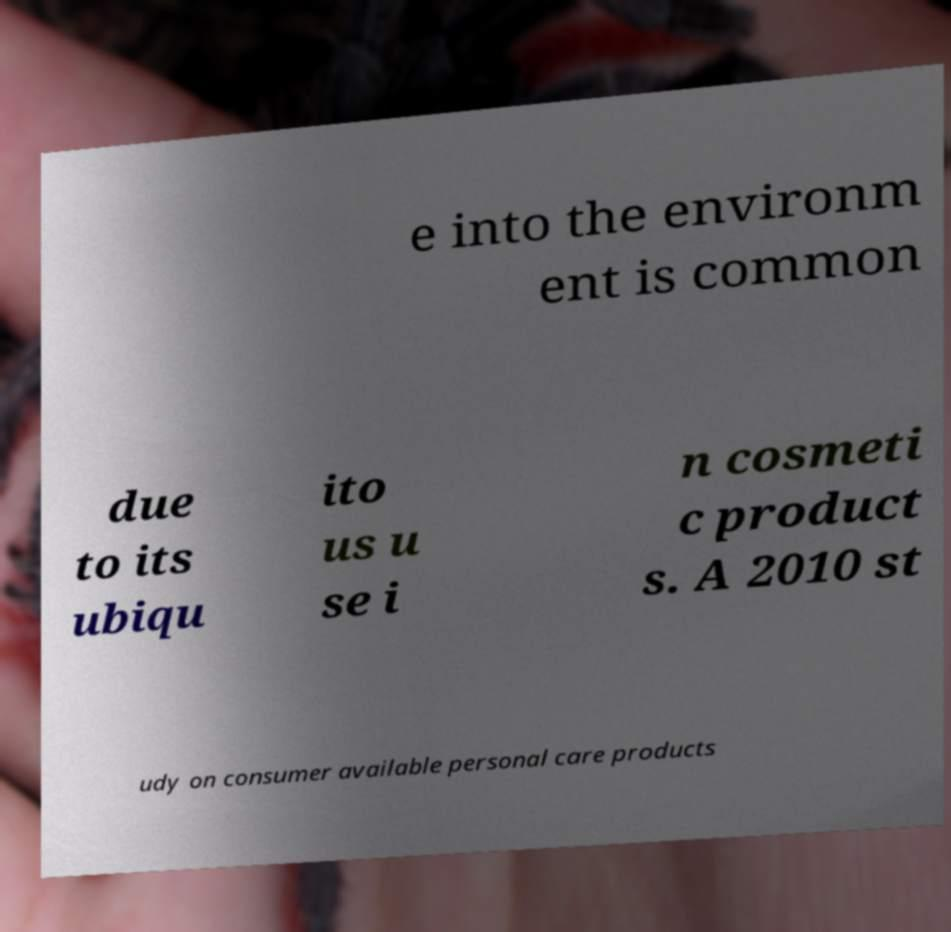Can you read and provide the text displayed in the image?This photo seems to have some interesting text. Can you extract and type it out for me? e into the environm ent is common due to its ubiqu ito us u se i n cosmeti c product s. A 2010 st udy on consumer available personal care products 